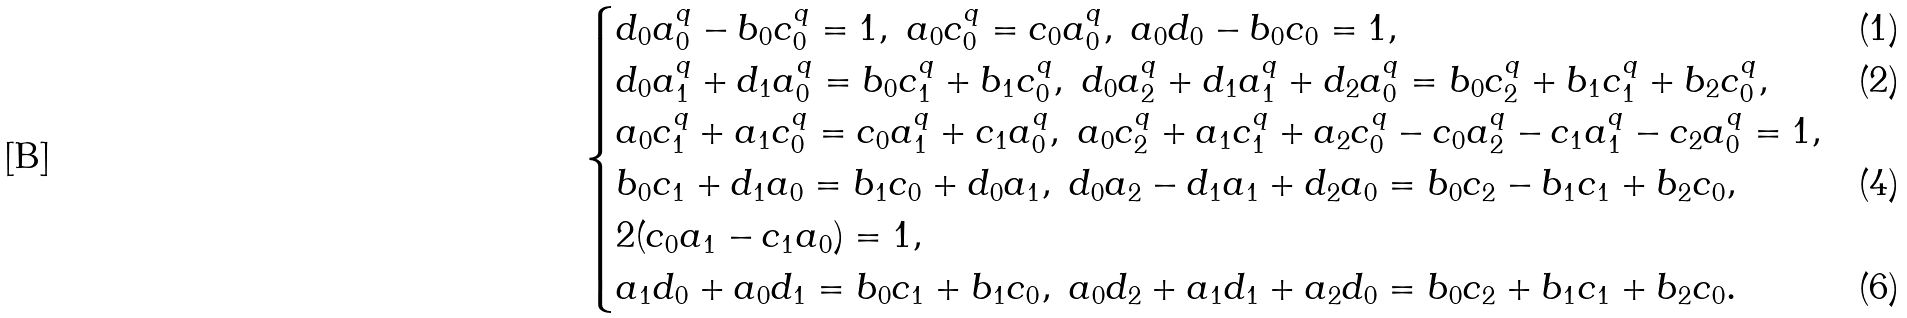Convert formula to latex. <formula><loc_0><loc_0><loc_500><loc_500>\begin{cases} d _ { 0 } a _ { 0 } ^ { q } - b _ { 0 } c _ { 0 } ^ { q } = 1 , \ a _ { 0 } c _ { 0 } ^ { q } = c _ { 0 } a _ { 0 } ^ { q } , \ a _ { 0 } d _ { 0 } - b _ { 0 } c _ { 0 } = 1 , & ( 1 ) \\ d _ { 0 } a _ { 1 } ^ { q } + d _ { 1 } a _ { 0 } ^ { q } = b _ { 0 } c _ { 1 } ^ { q } + b _ { 1 } c _ { 0 } ^ { q } , \ d _ { 0 } a _ { 2 } ^ { q } + d _ { 1 } a _ { 1 } ^ { q } + d _ { 2 } a _ { 0 } ^ { q } = b _ { 0 } c _ { 2 } ^ { q } + b _ { 1 } c _ { 1 } ^ { q } + b _ { 2 } c _ { 0 } ^ { q } , \ \ & ( 2 ) \\ a _ { 0 } c _ { 1 } ^ { q } + a _ { 1 } c _ { 0 } ^ { q } = c _ { 0 } a _ { 1 } ^ { q } + c _ { 1 } a _ { 0 } ^ { q } , \ a _ { 0 } c _ { 2 } ^ { q } + a _ { 1 } c _ { 1 } ^ { q } + a _ { 2 } c _ { 0 } ^ { q } - c _ { 0 } a _ { 2 } ^ { q } - c _ { 1 } a _ { 1 } ^ { q } - c _ { 2 } a _ { 0 } ^ { q } = 1 , \\ b _ { 0 } c _ { 1 } + d _ { 1 } a _ { 0 } = b _ { 1 } c _ { 0 } + d _ { 0 } a _ { 1 } , \ d _ { 0 } a _ { 2 } - d _ { 1 } a _ { 1 } + d _ { 2 } a _ { 0 } = b _ { 0 } c _ { 2 } - b _ { 1 } c _ { 1 } + b _ { 2 } c _ { 0 } , & ( 4 ) \\ 2 ( c _ { 0 } a _ { 1 } - c _ { 1 } a _ { 0 } ) = 1 , \\ a _ { 1 } d _ { 0 } + a _ { 0 } d _ { 1 } = b _ { 0 } c _ { 1 } + b _ { 1 } c _ { 0 } , \ a _ { 0 } d _ { 2 } + a _ { 1 } d _ { 1 } + a _ { 2 } d _ { 0 } = b _ { 0 } c _ { 2 } + b _ { 1 } c _ { 1 } + b _ { 2 } c _ { 0 } . & ( 6 ) \end{cases}</formula> 